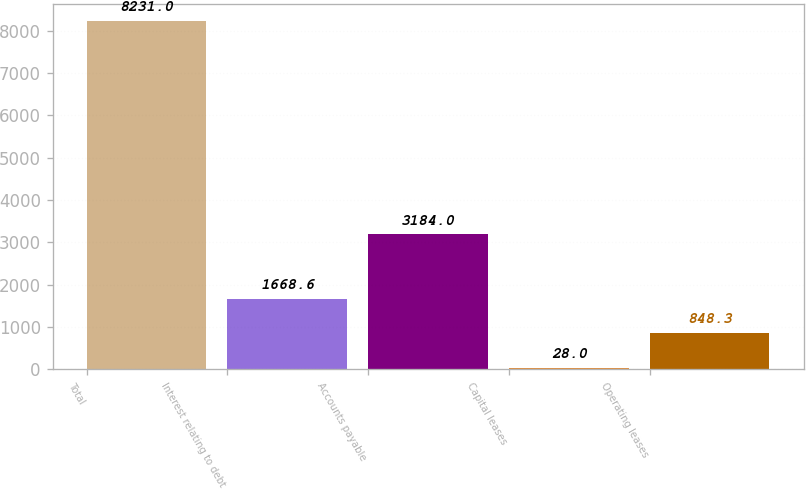Convert chart to OTSL. <chart><loc_0><loc_0><loc_500><loc_500><bar_chart><fcel>Total<fcel>Interest relating to debt<fcel>Accounts payable<fcel>Capital leases<fcel>Operating leases<nl><fcel>8231<fcel>1668.6<fcel>3184<fcel>28<fcel>848.3<nl></chart> 